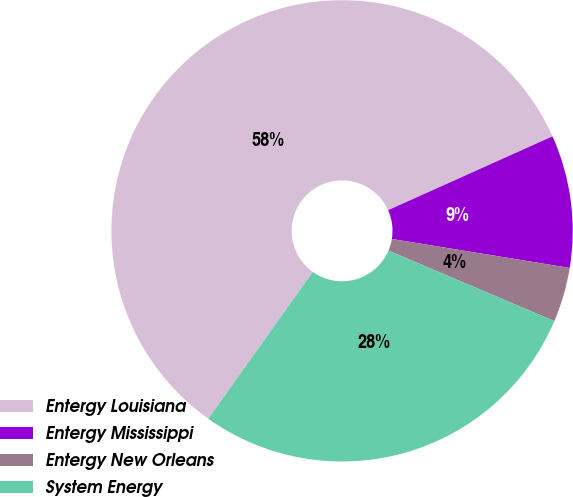Convert chart. <chart><loc_0><loc_0><loc_500><loc_500><pie_chart><fcel>Entergy Louisiana<fcel>Entergy Mississippi<fcel>Entergy New Orleans<fcel>System Energy<nl><fcel>58.43%<fcel>9.29%<fcel>3.83%<fcel>28.45%<nl></chart> 